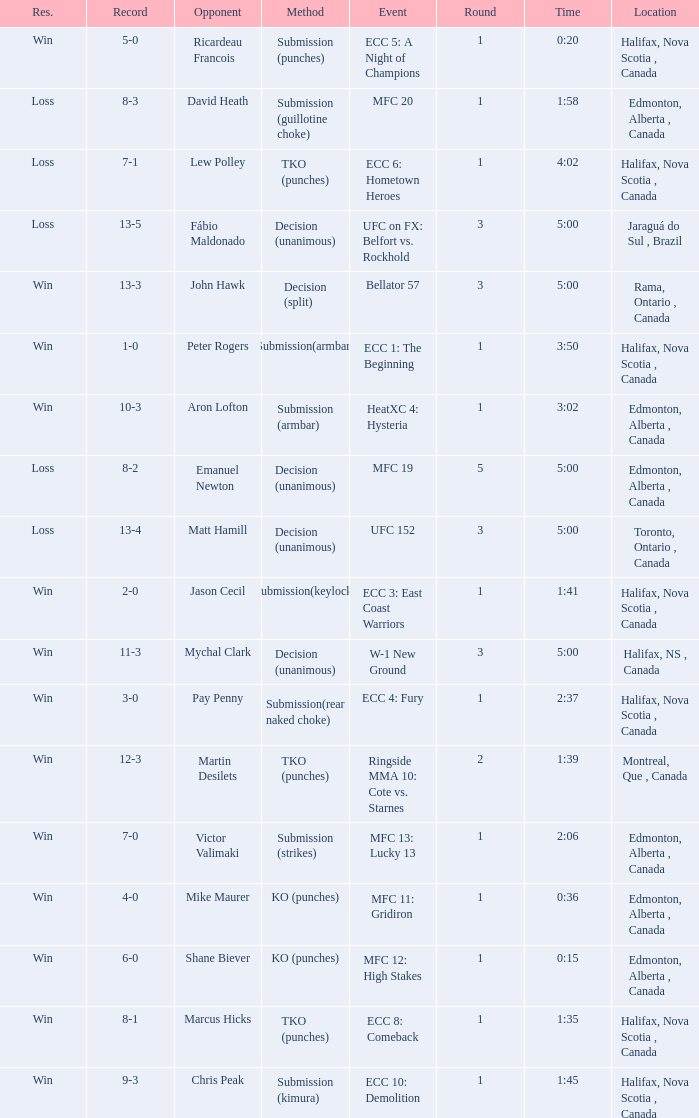What is the location of the match with Aron Lofton as the opponent? Edmonton, Alberta , Canada. 